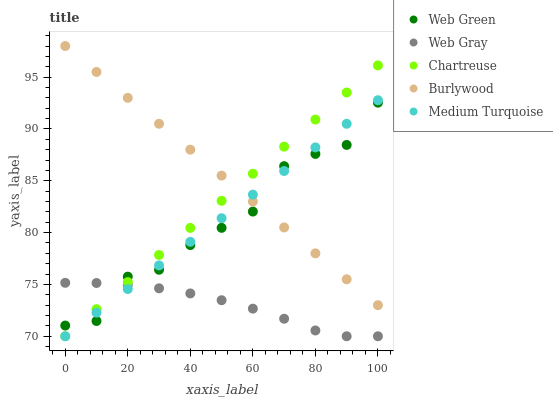Does Web Gray have the minimum area under the curve?
Answer yes or no. Yes. Does Burlywood have the maximum area under the curve?
Answer yes or no. Yes. Does Chartreuse have the minimum area under the curve?
Answer yes or no. No. Does Chartreuse have the maximum area under the curve?
Answer yes or no. No. Is Medium Turquoise the smoothest?
Answer yes or no. Yes. Is Web Green the roughest?
Answer yes or no. Yes. Is Chartreuse the smoothest?
Answer yes or no. No. Is Chartreuse the roughest?
Answer yes or no. No. Does Chartreuse have the lowest value?
Answer yes or no. Yes. Does Web Green have the lowest value?
Answer yes or no. No. Does Burlywood have the highest value?
Answer yes or no. Yes. Does Chartreuse have the highest value?
Answer yes or no. No. Is Web Gray less than Burlywood?
Answer yes or no. Yes. Is Burlywood greater than Web Gray?
Answer yes or no. Yes. Does Web Gray intersect Chartreuse?
Answer yes or no. Yes. Is Web Gray less than Chartreuse?
Answer yes or no. No. Is Web Gray greater than Chartreuse?
Answer yes or no. No. Does Web Gray intersect Burlywood?
Answer yes or no. No. 